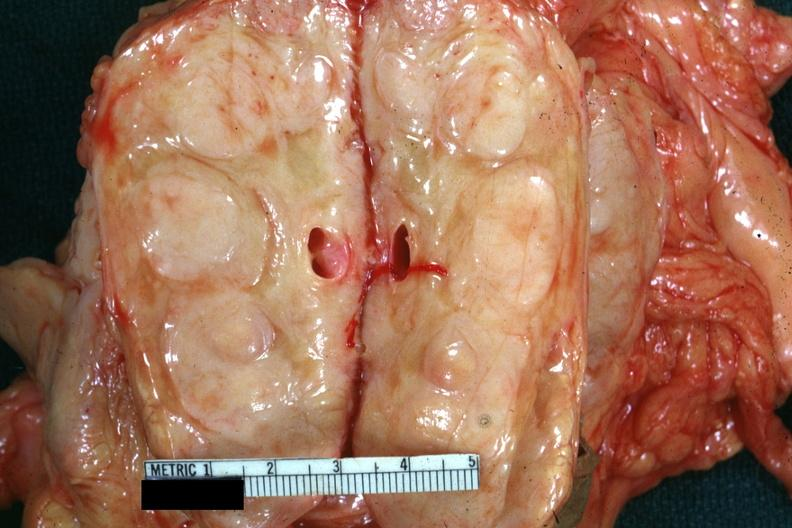what is present?
Answer the question using a single word or phrase. Lymph node 